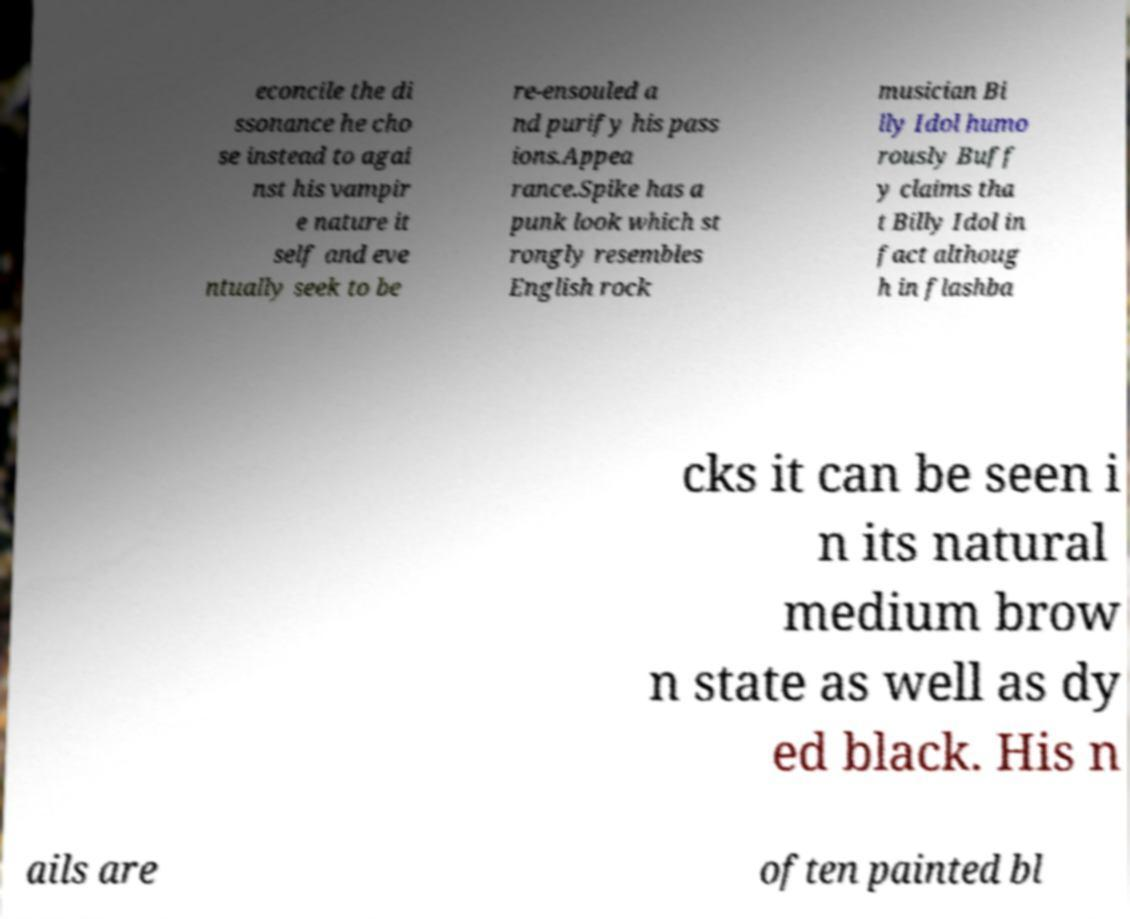Can you accurately transcribe the text from the provided image for me? econcile the di ssonance he cho se instead to agai nst his vampir e nature it self and eve ntually seek to be re-ensouled a nd purify his pass ions.Appea rance.Spike has a punk look which st rongly resembles English rock musician Bi lly Idol humo rously Buff y claims tha t Billy Idol in fact althoug h in flashba cks it can be seen i n its natural medium brow n state as well as dy ed black. His n ails are often painted bl 